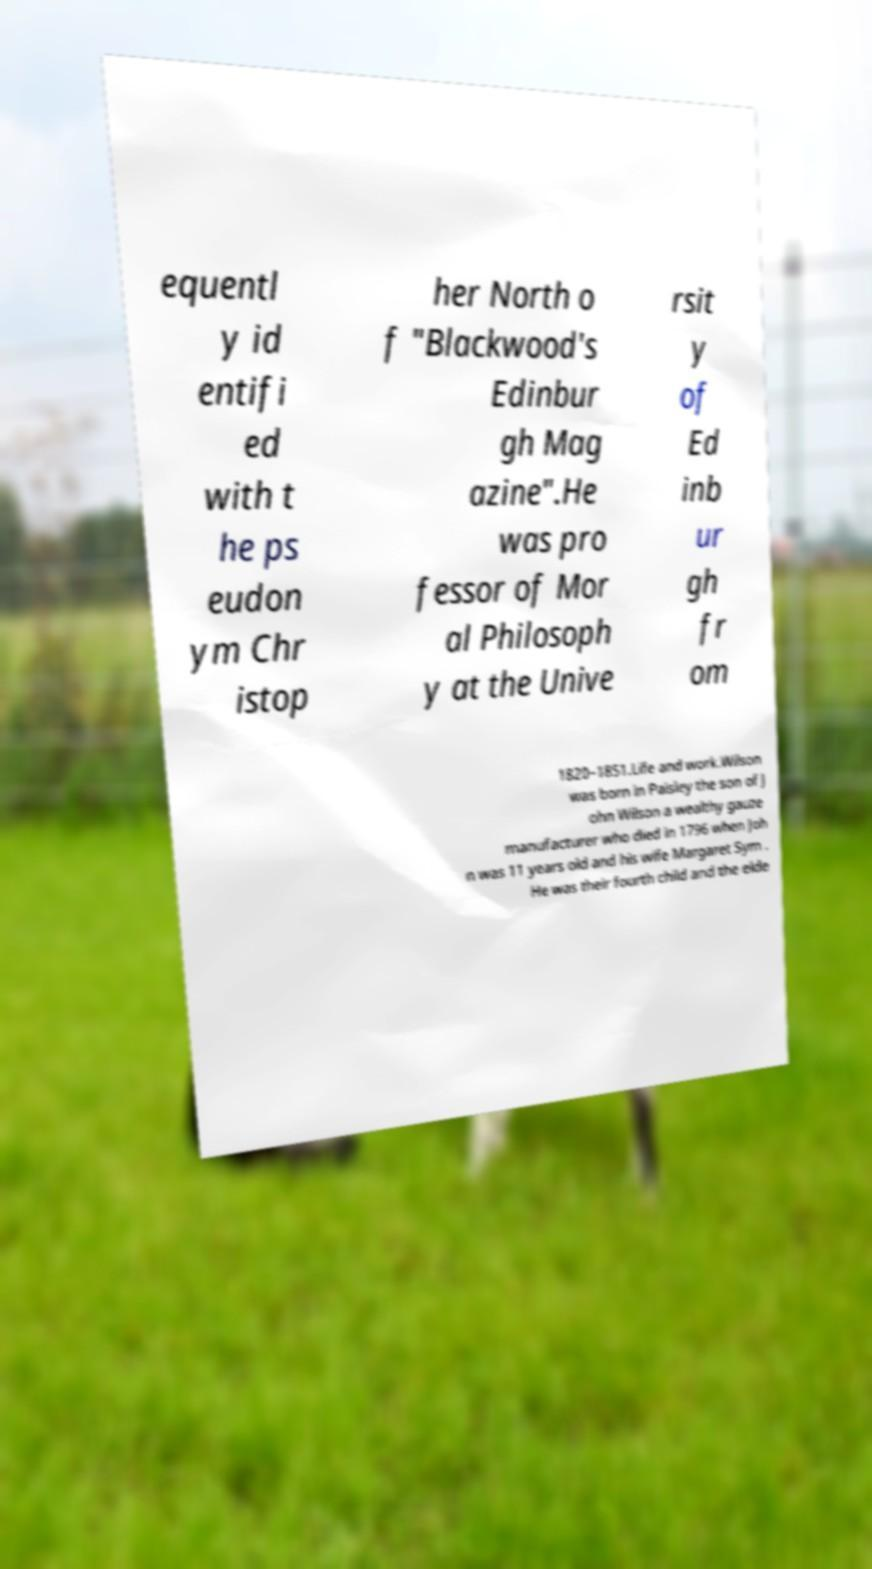Could you assist in decoding the text presented in this image and type it out clearly? equentl y id entifi ed with t he ps eudon ym Chr istop her North o f "Blackwood's Edinbur gh Mag azine".He was pro fessor of Mor al Philosoph y at the Unive rsit y of Ed inb ur gh fr om 1820–1851.Life and work.Wilson was born in Paisley the son of J ohn Wilson a wealthy gauze manufacturer who died in 1796 when Joh n was 11 years old and his wife Margaret Sym . He was their fourth child and the elde 